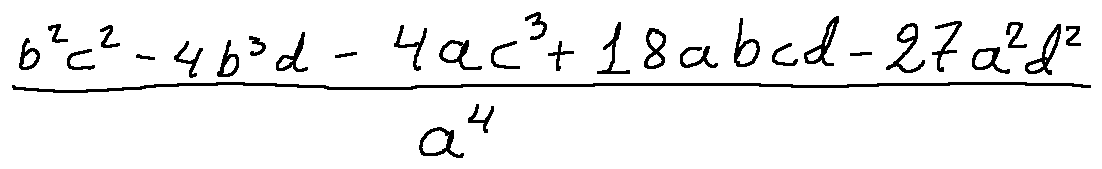Convert formula to latex. <formula><loc_0><loc_0><loc_500><loc_500>\frac { b ^ { 2 } c ^ { 2 } - 4 b ^ { 3 } d - 4 a c ^ { 3 } + 1 8 a b c d - 2 7 a ^ { 2 } d ^ { 2 } } { a ^ { 4 } }</formula> 